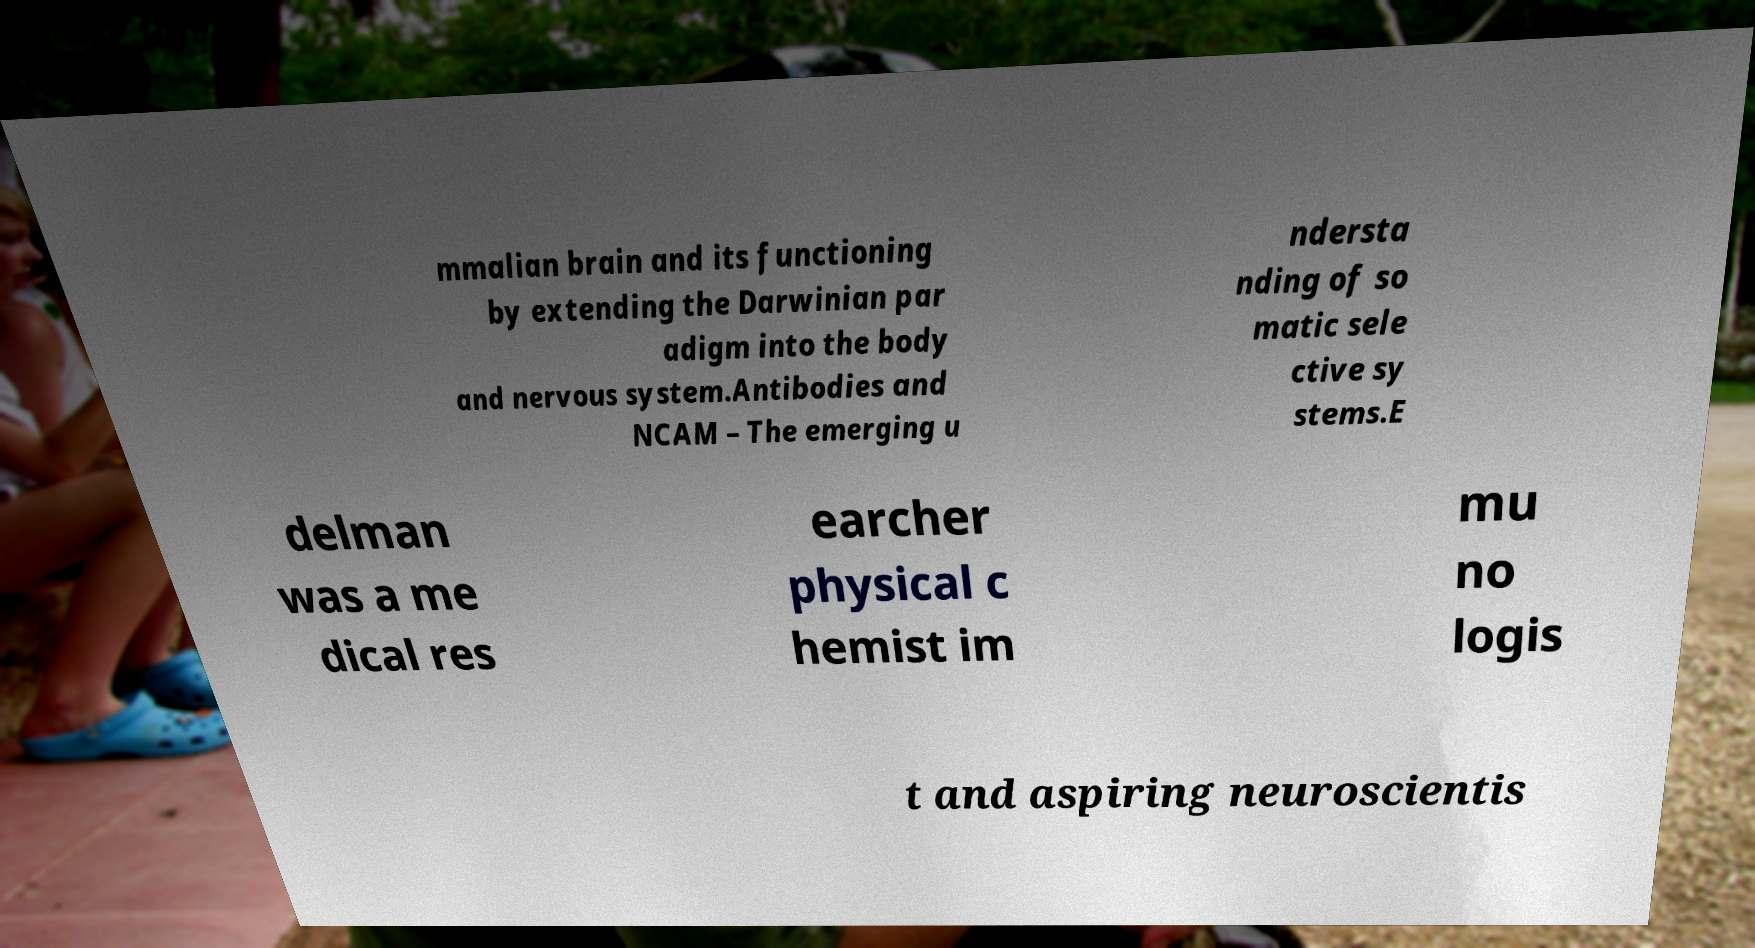There's text embedded in this image that I need extracted. Can you transcribe it verbatim? mmalian brain and its functioning by extending the Darwinian par adigm into the body and nervous system.Antibodies and NCAM – The emerging u ndersta nding of so matic sele ctive sy stems.E delman was a me dical res earcher physical c hemist im mu no logis t and aspiring neuroscientis 